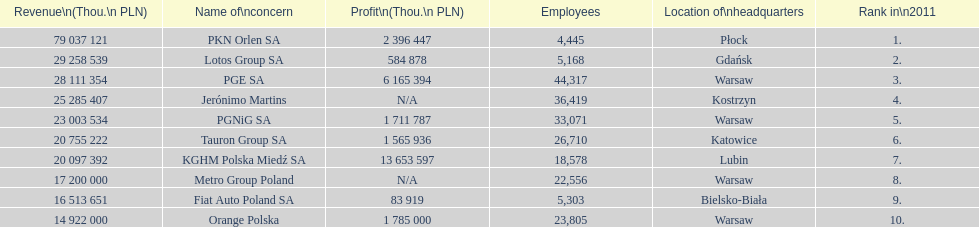What company is the only one with a revenue greater than 75,000,000 thou. pln? PKN Orlen SA. 